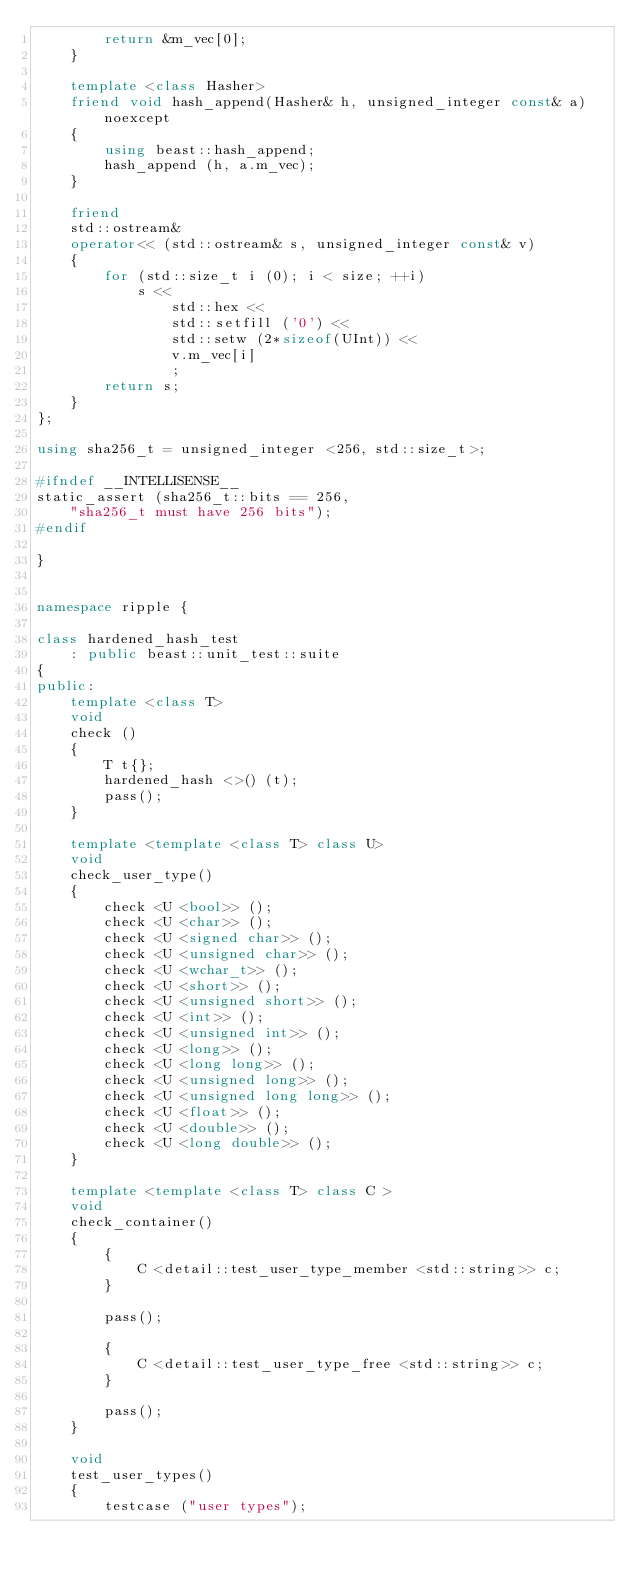Convert code to text. <code><loc_0><loc_0><loc_500><loc_500><_C++_>        return &m_vec[0];
    }

    template <class Hasher>
    friend void hash_append(Hasher& h, unsigned_integer const& a) noexcept
    {
        using beast::hash_append;
        hash_append (h, a.m_vec);
    }

    friend
    std::ostream&
    operator<< (std::ostream& s, unsigned_integer const& v)
    {
        for (std::size_t i (0); i < size; ++i)
            s <<
                std::hex <<
                std::setfill ('0') <<
                std::setw (2*sizeof(UInt)) <<
                v.m_vec[i]
                ;
        return s;
    }
};

using sha256_t = unsigned_integer <256, std::size_t>;

#ifndef __INTELLISENSE__
static_assert (sha256_t::bits == 256,
    "sha256_t must have 256 bits");
#endif

} 


namespace ripple {

class hardened_hash_test
    : public beast::unit_test::suite
{
public:
    template <class T>
    void
    check ()
    {
        T t{};
        hardened_hash <>() (t);
        pass();
    }

    template <template <class T> class U>
    void
    check_user_type()
    {
        check <U <bool>> ();
        check <U <char>> ();
        check <U <signed char>> ();
        check <U <unsigned char>> ();
        check <U <wchar_t>> ();
        check <U <short>> ();
        check <U <unsigned short>> ();
        check <U <int>> ();
        check <U <unsigned int>> ();
        check <U <long>> ();
        check <U <long long>> ();
        check <U <unsigned long>> ();
        check <U <unsigned long long>> ();
        check <U <float>> ();
        check <U <double>> ();
        check <U <long double>> ();
    }

    template <template <class T> class C >
    void
    check_container()
    {
        {
            C <detail::test_user_type_member <std::string>> c;
        }

        pass();

        {
            C <detail::test_user_type_free <std::string>> c;
        }

        pass();
    }

    void
    test_user_types()
    {
        testcase ("user types");</code> 